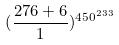Convert formula to latex. <formula><loc_0><loc_0><loc_500><loc_500>( \frac { 2 7 6 + 6 } { 1 } ) ^ { 4 5 0 ^ { 2 3 3 } }</formula> 